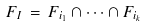<formula> <loc_0><loc_0><loc_500><loc_500>F _ { I } \, = \, F _ { i _ { 1 } } \cap \dots \cap F _ { i _ { k } }</formula> 